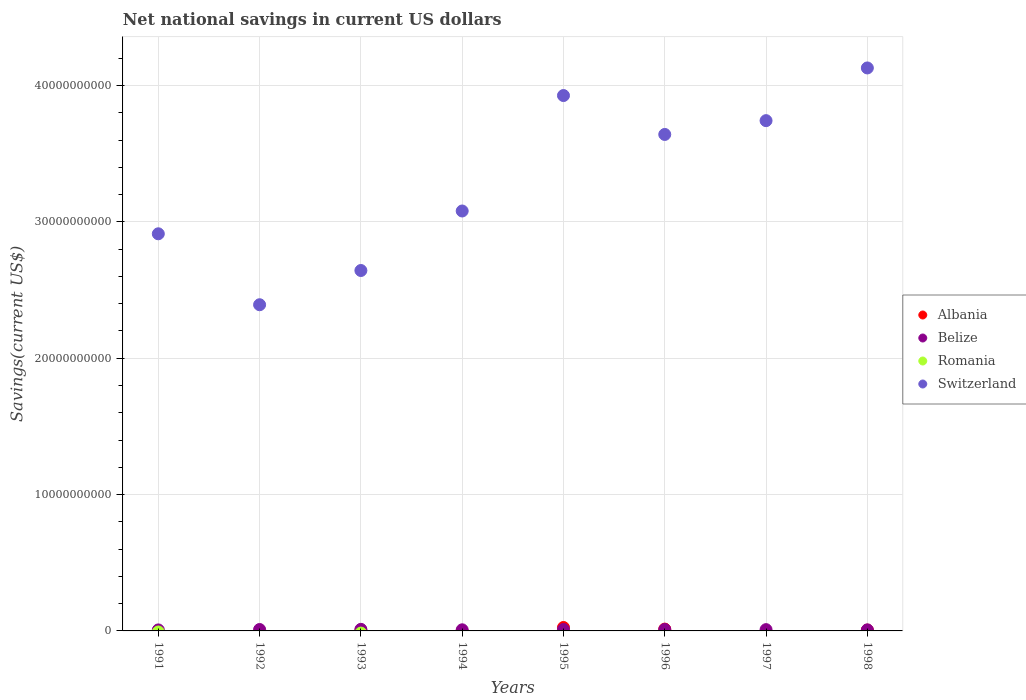How many different coloured dotlines are there?
Offer a terse response. 3. What is the net national savings in Belize in 1994?
Your answer should be compact. 8.16e+07. Across all years, what is the maximum net national savings in Belize?
Your response must be concise. 1.16e+08. Across all years, what is the minimum net national savings in Belize?
Provide a succinct answer. 7.34e+07. What is the total net national savings in Switzerland in the graph?
Keep it short and to the point. 2.65e+11. What is the difference between the net national savings in Switzerland in 1993 and that in 1998?
Your answer should be compact. -1.49e+1. What is the difference between the net national savings in Switzerland in 1991 and the net national savings in Romania in 1992?
Your response must be concise. 2.91e+1. What is the average net national savings in Albania per year?
Offer a very short reply. 5.68e+07. In the year 1991, what is the difference between the net national savings in Belize and net national savings in Switzerland?
Keep it short and to the point. -2.91e+1. What is the ratio of the net national savings in Switzerland in 1993 to that in 1997?
Provide a succinct answer. 0.71. What is the difference between the highest and the second highest net national savings in Belize?
Give a very brief answer. 8.36e+06. What is the difference between the highest and the lowest net national savings in Albania?
Provide a succinct answer. 2.51e+08. In how many years, is the net national savings in Romania greater than the average net national savings in Romania taken over all years?
Your answer should be compact. 0. Is it the case that in every year, the sum of the net national savings in Albania and net national savings in Switzerland  is greater than the net national savings in Belize?
Keep it short and to the point. Yes. What is the difference between two consecutive major ticks on the Y-axis?
Your answer should be very brief. 1.00e+1. Does the graph contain grids?
Your answer should be very brief. Yes. What is the title of the graph?
Provide a short and direct response. Net national savings in current US dollars. What is the label or title of the Y-axis?
Keep it short and to the point. Savings(current US$). What is the Savings(current US$) in Belize in 1991?
Provide a short and direct response. 7.34e+07. What is the Savings(current US$) in Romania in 1991?
Your response must be concise. 0. What is the Savings(current US$) of Switzerland in 1991?
Provide a short and direct response. 2.91e+1. What is the Savings(current US$) in Albania in 1992?
Make the answer very short. 0. What is the Savings(current US$) in Belize in 1992?
Offer a very short reply. 1.03e+08. What is the Savings(current US$) of Switzerland in 1992?
Give a very brief answer. 2.39e+1. What is the Savings(current US$) in Albania in 1993?
Make the answer very short. 1.18e+07. What is the Savings(current US$) of Belize in 1993?
Provide a succinct answer. 1.16e+08. What is the Savings(current US$) of Switzerland in 1993?
Keep it short and to the point. 2.64e+1. What is the Savings(current US$) in Belize in 1994?
Give a very brief answer. 8.16e+07. What is the Savings(current US$) of Switzerland in 1994?
Ensure brevity in your answer.  3.08e+1. What is the Savings(current US$) of Albania in 1995?
Provide a succinct answer. 2.51e+08. What is the Savings(current US$) in Belize in 1995?
Keep it short and to the point. 1.07e+08. What is the Savings(current US$) of Switzerland in 1995?
Provide a succinct answer. 3.93e+1. What is the Savings(current US$) of Albania in 1996?
Give a very brief answer. 1.33e+08. What is the Savings(current US$) of Belize in 1996?
Your response must be concise. 1.06e+08. What is the Savings(current US$) of Romania in 1996?
Give a very brief answer. 0. What is the Savings(current US$) in Switzerland in 1996?
Provide a short and direct response. 3.64e+1. What is the Savings(current US$) in Belize in 1997?
Your response must be concise. 9.42e+07. What is the Savings(current US$) of Romania in 1997?
Give a very brief answer. 0. What is the Savings(current US$) in Switzerland in 1997?
Offer a very short reply. 3.74e+1. What is the Savings(current US$) in Albania in 1998?
Keep it short and to the point. 5.77e+07. What is the Savings(current US$) in Belize in 1998?
Keep it short and to the point. 7.81e+07. What is the Savings(current US$) of Romania in 1998?
Your answer should be very brief. 0. What is the Savings(current US$) in Switzerland in 1998?
Give a very brief answer. 4.13e+1. Across all years, what is the maximum Savings(current US$) in Albania?
Ensure brevity in your answer.  2.51e+08. Across all years, what is the maximum Savings(current US$) of Belize?
Keep it short and to the point. 1.16e+08. Across all years, what is the maximum Savings(current US$) of Switzerland?
Your answer should be very brief. 4.13e+1. Across all years, what is the minimum Savings(current US$) in Albania?
Offer a very short reply. 0. Across all years, what is the minimum Savings(current US$) in Belize?
Ensure brevity in your answer.  7.34e+07. Across all years, what is the minimum Savings(current US$) of Switzerland?
Your answer should be very brief. 2.39e+1. What is the total Savings(current US$) of Albania in the graph?
Your answer should be very brief. 4.54e+08. What is the total Savings(current US$) of Belize in the graph?
Your answer should be compact. 7.60e+08. What is the total Savings(current US$) of Switzerland in the graph?
Your answer should be very brief. 2.65e+11. What is the difference between the Savings(current US$) in Belize in 1991 and that in 1992?
Give a very brief answer. -3.00e+07. What is the difference between the Savings(current US$) of Switzerland in 1991 and that in 1992?
Offer a very short reply. 5.20e+09. What is the difference between the Savings(current US$) in Belize in 1991 and that in 1993?
Make the answer very short. -4.24e+07. What is the difference between the Savings(current US$) of Switzerland in 1991 and that in 1993?
Your answer should be compact. 2.69e+09. What is the difference between the Savings(current US$) in Belize in 1991 and that in 1994?
Make the answer very short. -8.23e+06. What is the difference between the Savings(current US$) of Switzerland in 1991 and that in 1994?
Your answer should be very brief. -1.67e+09. What is the difference between the Savings(current US$) of Belize in 1991 and that in 1995?
Your answer should be compact. -3.41e+07. What is the difference between the Savings(current US$) in Switzerland in 1991 and that in 1995?
Ensure brevity in your answer.  -1.01e+1. What is the difference between the Savings(current US$) of Belize in 1991 and that in 1996?
Your response must be concise. -3.30e+07. What is the difference between the Savings(current US$) of Switzerland in 1991 and that in 1996?
Keep it short and to the point. -7.29e+09. What is the difference between the Savings(current US$) in Belize in 1991 and that in 1997?
Offer a terse response. -2.08e+07. What is the difference between the Savings(current US$) of Switzerland in 1991 and that in 1997?
Provide a succinct answer. -8.30e+09. What is the difference between the Savings(current US$) in Belize in 1991 and that in 1998?
Keep it short and to the point. -4.71e+06. What is the difference between the Savings(current US$) in Switzerland in 1991 and that in 1998?
Keep it short and to the point. -1.22e+1. What is the difference between the Savings(current US$) in Belize in 1992 and that in 1993?
Your response must be concise. -1.25e+07. What is the difference between the Savings(current US$) of Switzerland in 1992 and that in 1993?
Make the answer very short. -2.51e+09. What is the difference between the Savings(current US$) in Belize in 1992 and that in 1994?
Provide a succinct answer. 2.18e+07. What is the difference between the Savings(current US$) of Switzerland in 1992 and that in 1994?
Your answer should be compact. -6.88e+09. What is the difference between the Savings(current US$) in Belize in 1992 and that in 1995?
Offer a very short reply. -4.10e+06. What is the difference between the Savings(current US$) of Switzerland in 1992 and that in 1995?
Give a very brief answer. -1.53e+1. What is the difference between the Savings(current US$) in Belize in 1992 and that in 1996?
Make the answer very short. -3.06e+06. What is the difference between the Savings(current US$) in Switzerland in 1992 and that in 1996?
Provide a short and direct response. -1.25e+1. What is the difference between the Savings(current US$) in Belize in 1992 and that in 1997?
Ensure brevity in your answer.  9.16e+06. What is the difference between the Savings(current US$) in Switzerland in 1992 and that in 1997?
Make the answer very short. -1.35e+1. What is the difference between the Savings(current US$) of Belize in 1992 and that in 1998?
Give a very brief answer. 2.53e+07. What is the difference between the Savings(current US$) in Switzerland in 1992 and that in 1998?
Provide a short and direct response. -1.74e+1. What is the difference between the Savings(current US$) of Belize in 1993 and that in 1994?
Offer a terse response. 3.42e+07. What is the difference between the Savings(current US$) of Switzerland in 1993 and that in 1994?
Provide a short and direct response. -4.37e+09. What is the difference between the Savings(current US$) in Albania in 1993 and that in 1995?
Give a very brief answer. -2.39e+08. What is the difference between the Savings(current US$) of Belize in 1993 and that in 1995?
Offer a terse response. 8.36e+06. What is the difference between the Savings(current US$) in Switzerland in 1993 and that in 1995?
Ensure brevity in your answer.  -1.28e+1. What is the difference between the Savings(current US$) in Albania in 1993 and that in 1996?
Ensure brevity in your answer.  -1.22e+08. What is the difference between the Savings(current US$) in Belize in 1993 and that in 1996?
Your response must be concise. 9.40e+06. What is the difference between the Savings(current US$) in Switzerland in 1993 and that in 1996?
Offer a very short reply. -9.98e+09. What is the difference between the Savings(current US$) in Belize in 1993 and that in 1997?
Provide a succinct answer. 2.16e+07. What is the difference between the Savings(current US$) in Switzerland in 1993 and that in 1997?
Make the answer very short. -1.10e+1. What is the difference between the Savings(current US$) in Albania in 1993 and that in 1998?
Your response must be concise. -4.59e+07. What is the difference between the Savings(current US$) of Belize in 1993 and that in 1998?
Give a very brief answer. 3.77e+07. What is the difference between the Savings(current US$) of Switzerland in 1993 and that in 1998?
Keep it short and to the point. -1.49e+1. What is the difference between the Savings(current US$) of Belize in 1994 and that in 1995?
Provide a short and direct response. -2.59e+07. What is the difference between the Savings(current US$) in Switzerland in 1994 and that in 1995?
Offer a very short reply. -8.47e+09. What is the difference between the Savings(current US$) of Belize in 1994 and that in 1996?
Offer a terse response. -2.48e+07. What is the difference between the Savings(current US$) in Switzerland in 1994 and that in 1996?
Keep it short and to the point. -5.61e+09. What is the difference between the Savings(current US$) of Belize in 1994 and that in 1997?
Make the answer very short. -1.26e+07. What is the difference between the Savings(current US$) in Switzerland in 1994 and that in 1997?
Offer a terse response. -6.63e+09. What is the difference between the Savings(current US$) of Belize in 1994 and that in 1998?
Offer a terse response. 3.52e+06. What is the difference between the Savings(current US$) in Switzerland in 1994 and that in 1998?
Your answer should be compact. -1.05e+1. What is the difference between the Savings(current US$) of Albania in 1995 and that in 1996?
Your answer should be compact. 1.18e+08. What is the difference between the Savings(current US$) in Belize in 1995 and that in 1996?
Your answer should be compact. 1.04e+06. What is the difference between the Savings(current US$) of Switzerland in 1995 and that in 1996?
Provide a succinct answer. 2.85e+09. What is the difference between the Savings(current US$) in Belize in 1995 and that in 1997?
Provide a succinct answer. 1.33e+07. What is the difference between the Savings(current US$) in Switzerland in 1995 and that in 1997?
Your answer should be very brief. 1.84e+09. What is the difference between the Savings(current US$) of Albania in 1995 and that in 1998?
Your response must be concise. 1.94e+08. What is the difference between the Savings(current US$) of Belize in 1995 and that in 1998?
Ensure brevity in your answer.  2.94e+07. What is the difference between the Savings(current US$) in Switzerland in 1995 and that in 1998?
Offer a terse response. -2.02e+09. What is the difference between the Savings(current US$) in Belize in 1996 and that in 1997?
Your answer should be very brief. 1.22e+07. What is the difference between the Savings(current US$) in Switzerland in 1996 and that in 1997?
Give a very brief answer. -1.01e+09. What is the difference between the Savings(current US$) of Albania in 1996 and that in 1998?
Provide a short and direct response. 7.57e+07. What is the difference between the Savings(current US$) in Belize in 1996 and that in 1998?
Provide a succinct answer. 2.83e+07. What is the difference between the Savings(current US$) of Switzerland in 1996 and that in 1998?
Your answer should be very brief. -4.88e+09. What is the difference between the Savings(current US$) of Belize in 1997 and that in 1998?
Your answer should be compact. 1.61e+07. What is the difference between the Savings(current US$) in Switzerland in 1997 and that in 1998?
Offer a very short reply. -3.87e+09. What is the difference between the Savings(current US$) in Belize in 1991 and the Savings(current US$) in Switzerland in 1992?
Your response must be concise. -2.39e+1. What is the difference between the Savings(current US$) in Belize in 1991 and the Savings(current US$) in Switzerland in 1993?
Make the answer very short. -2.64e+1. What is the difference between the Savings(current US$) of Belize in 1991 and the Savings(current US$) of Switzerland in 1994?
Provide a short and direct response. -3.07e+1. What is the difference between the Savings(current US$) of Belize in 1991 and the Savings(current US$) of Switzerland in 1995?
Give a very brief answer. -3.92e+1. What is the difference between the Savings(current US$) in Belize in 1991 and the Savings(current US$) in Switzerland in 1996?
Your answer should be compact. -3.63e+1. What is the difference between the Savings(current US$) in Belize in 1991 and the Savings(current US$) in Switzerland in 1997?
Your answer should be very brief. -3.74e+1. What is the difference between the Savings(current US$) in Belize in 1991 and the Savings(current US$) in Switzerland in 1998?
Offer a very short reply. -4.12e+1. What is the difference between the Savings(current US$) in Belize in 1992 and the Savings(current US$) in Switzerland in 1993?
Offer a very short reply. -2.63e+1. What is the difference between the Savings(current US$) of Belize in 1992 and the Savings(current US$) of Switzerland in 1994?
Provide a succinct answer. -3.07e+1. What is the difference between the Savings(current US$) in Belize in 1992 and the Savings(current US$) in Switzerland in 1995?
Keep it short and to the point. -3.92e+1. What is the difference between the Savings(current US$) of Belize in 1992 and the Savings(current US$) of Switzerland in 1996?
Your answer should be very brief. -3.63e+1. What is the difference between the Savings(current US$) in Belize in 1992 and the Savings(current US$) in Switzerland in 1997?
Make the answer very short. -3.73e+1. What is the difference between the Savings(current US$) of Belize in 1992 and the Savings(current US$) of Switzerland in 1998?
Provide a short and direct response. -4.12e+1. What is the difference between the Savings(current US$) of Albania in 1993 and the Savings(current US$) of Belize in 1994?
Your answer should be very brief. -6.98e+07. What is the difference between the Savings(current US$) in Albania in 1993 and the Savings(current US$) in Switzerland in 1994?
Keep it short and to the point. -3.08e+1. What is the difference between the Savings(current US$) in Belize in 1993 and the Savings(current US$) in Switzerland in 1994?
Provide a succinct answer. -3.07e+1. What is the difference between the Savings(current US$) of Albania in 1993 and the Savings(current US$) of Belize in 1995?
Ensure brevity in your answer.  -9.57e+07. What is the difference between the Savings(current US$) of Albania in 1993 and the Savings(current US$) of Switzerland in 1995?
Make the answer very short. -3.93e+1. What is the difference between the Savings(current US$) of Belize in 1993 and the Savings(current US$) of Switzerland in 1995?
Your answer should be very brief. -3.92e+1. What is the difference between the Savings(current US$) in Albania in 1993 and the Savings(current US$) in Belize in 1996?
Make the answer very short. -9.46e+07. What is the difference between the Savings(current US$) of Albania in 1993 and the Savings(current US$) of Switzerland in 1996?
Provide a short and direct response. -3.64e+1. What is the difference between the Savings(current US$) of Belize in 1993 and the Savings(current US$) of Switzerland in 1996?
Keep it short and to the point. -3.63e+1. What is the difference between the Savings(current US$) in Albania in 1993 and the Savings(current US$) in Belize in 1997?
Provide a short and direct response. -8.24e+07. What is the difference between the Savings(current US$) of Albania in 1993 and the Savings(current US$) of Switzerland in 1997?
Provide a succinct answer. -3.74e+1. What is the difference between the Savings(current US$) of Belize in 1993 and the Savings(current US$) of Switzerland in 1997?
Provide a short and direct response. -3.73e+1. What is the difference between the Savings(current US$) of Albania in 1993 and the Savings(current US$) of Belize in 1998?
Provide a succinct answer. -6.63e+07. What is the difference between the Savings(current US$) of Albania in 1993 and the Savings(current US$) of Switzerland in 1998?
Your response must be concise. -4.13e+1. What is the difference between the Savings(current US$) of Belize in 1993 and the Savings(current US$) of Switzerland in 1998?
Offer a very short reply. -4.12e+1. What is the difference between the Savings(current US$) of Belize in 1994 and the Savings(current US$) of Switzerland in 1995?
Make the answer very short. -3.92e+1. What is the difference between the Savings(current US$) of Belize in 1994 and the Savings(current US$) of Switzerland in 1996?
Provide a succinct answer. -3.63e+1. What is the difference between the Savings(current US$) of Belize in 1994 and the Savings(current US$) of Switzerland in 1997?
Your answer should be very brief. -3.73e+1. What is the difference between the Savings(current US$) in Belize in 1994 and the Savings(current US$) in Switzerland in 1998?
Your response must be concise. -4.12e+1. What is the difference between the Savings(current US$) in Albania in 1995 and the Savings(current US$) in Belize in 1996?
Make the answer very short. 1.45e+08. What is the difference between the Savings(current US$) in Albania in 1995 and the Savings(current US$) in Switzerland in 1996?
Ensure brevity in your answer.  -3.62e+1. What is the difference between the Savings(current US$) in Belize in 1995 and the Savings(current US$) in Switzerland in 1996?
Offer a very short reply. -3.63e+1. What is the difference between the Savings(current US$) of Albania in 1995 and the Savings(current US$) of Belize in 1997?
Give a very brief answer. 1.57e+08. What is the difference between the Savings(current US$) in Albania in 1995 and the Savings(current US$) in Switzerland in 1997?
Your answer should be compact. -3.72e+1. What is the difference between the Savings(current US$) of Belize in 1995 and the Savings(current US$) of Switzerland in 1997?
Make the answer very short. -3.73e+1. What is the difference between the Savings(current US$) of Albania in 1995 and the Savings(current US$) of Belize in 1998?
Make the answer very short. 1.73e+08. What is the difference between the Savings(current US$) in Albania in 1995 and the Savings(current US$) in Switzerland in 1998?
Make the answer very short. -4.10e+1. What is the difference between the Savings(current US$) of Belize in 1995 and the Savings(current US$) of Switzerland in 1998?
Make the answer very short. -4.12e+1. What is the difference between the Savings(current US$) of Albania in 1996 and the Savings(current US$) of Belize in 1997?
Keep it short and to the point. 3.92e+07. What is the difference between the Savings(current US$) of Albania in 1996 and the Savings(current US$) of Switzerland in 1997?
Ensure brevity in your answer.  -3.73e+1. What is the difference between the Savings(current US$) in Belize in 1996 and the Savings(current US$) in Switzerland in 1997?
Offer a terse response. -3.73e+1. What is the difference between the Savings(current US$) in Albania in 1996 and the Savings(current US$) in Belize in 1998?
Keep it short and to the point. 5.53e+07. What is the difference between the Savings(current US$) in Albania in 1996 and the Savings(current US$) in Switzerland in 1998?
Offer a terse response. -4.12e+1. What is the difference between the Savings(current US$) of Belize in 1996 and the Savings(current US$) of Switzerland in 1998?
Offer a very short reply. -4.12e+1. What is the difference between the Savings(current US$) in Belize in 1997 and the Savings(current US$) in Switzerland in 1998?
Offer a very short reply. -4.12e+1. What is the average Savings(current US$) of Albania per year?
Offer a very short reply. 5.68e+07. What is the average Savings(current US$) of Belize per year?
Offer a very short reply. 9.50e+07. What is the average Savings(current US$) in Switzerland per year?
Your answer should be very brief. 3.31e+1. In the year 1991, what is the difference between the Savings(current US$) of Belize and Savings(current US$) of Switzerland?
Give a very brief answer. -2.91e+1. In the year 1992, what is the difference between the Savings(current US$) of Belize and Savings(current US$) of Switzerland?
Your answer should be compact. -2.38e+1. In the year 1993, what is the difference between the Savings(current US$) in Albania and Savings(current US$) in Belize?
Keep it short and to the point. -1.04e+08. In the year 1993, what is the difference between the Savings(current US$) of Albania and Savings(current US$) of Switzerland?
Offer a very short reply. -2.64e+1. In the year 1993, what is the difference between the Savings(current US$) in Belize and Savings(current US$) in Switzerland?
Keep it short and to the point. -2.63e+1. In the year 1994, what is the difference between the Savings(current US$) of Belize and Savings(current US$) of Switzerland?
Ensure brevity in your answer.  -3.07e+1. In the year 1995, what is the difference between the Savings(current US$) in Albania and Savings(current US$) in Belize?
Your answer should be compact. 1.44e+08. In the year 1995, what is the difference between the Savings(current US$) in Albania and Savings(current US$) in Switzerland?
Offer a terse response. -3.90e+1. In the year 1995, what is the difference between the Savings(current US$) in Belize and Savings(current US$) in Switzerland?
Provide a short and direct response. -3.92e+1. In the year 1996, what is the difference between the Savings(current US$) in Albania and Savings(current US$) in Belize?
Provide a short and direct response. 2.70e+07. In the year 1996, what is the difference between the Savings(current US$) in Albania and Savings(current US$) in Switzerland?
Provide a succinct answer. -3.63e+1. In the year 1996, what is the difference between the Savings(current US$) in Belize and Savings(current US$) in Switzerland?
Provide a succinct answer. -3.63e+1. In the year 1997, what is the difference between the Savings(current US$) of Belize and Savings(current US$) of Switzerland?
Your answer should be compact. -3.73e+1. In the year 1998, what is the difference between the Savings(current US$) of Albania and Savings(current US$) of Belize?
Offer a terse response. -2.04e+07. In the year 1998, what is the difference between the Savings(current US$) of Albania and Savings(current US$) of Switzerland?
Provide a succinct answer. -4.12e+1. In the year 1998, what is the difference between the Savings(current US$) in Belize and Savings(current US$) in Switzerland?
Offer a terse response. -4.12e+1. What is the ratio of the Savings(current US$) of Belize in 1991 to that in 1992?
Keep it short and to the point. 0.71. What is the ratio of the Savings(current US$) in Switzerland in 1991 to that in 1992?
Give a very brief answer. 1.22. What is the ratio of the Savings(current US$) of Belize in 1991 to that in 1993?
Offer a terse response. 0.63. What is the ratio of the Savings(current US$) in Switzerland in 1991 to that in 1993?
Give a very brief answer. 1.1. What is the ratio of the Savings(current US$) in Belize in 1991 to that in 1994?
Keep it short and to the point. 0.9. What is the ratio of the Savings(current US$) of Switzerland in 1991 to that in 1994?
Your response must be concise. 0.95. What is the ratio of the Savings(current US$) in Belize in 1991 to that in 1995?
Offer a terse response. 0.68. What is the ratio of the Savings(current US$) in Switzerland in 1991 to that in 1995?
Provide a succinct answer. 0.74. What is the ratio of the Savings(current US$) of Belize in 1991 to that in 1996?
Give a very brief answer. 0.69. What is the ratio of the Savings(current US$) in Switzerland in 1991 to that in 1996?
Your response must be concise. 0.8. What is the ratio of the Savings(current US$) of Belize in 1991 to that in 1997?
Offer a very short reply. 0.78. What is the ratio of the Savings(current US$) in Switzerland in 1991 to that in 1997?
Ensure brevity in your answer.  0.78. What is the ratio of the Savings(current US$) in Belize in 1991 to that in 1998?
Your answer should be compact. 0.94. What is the ratio of the Savings(current US$) in Switzerland in 1991 to that in 1998?
Offer a terse response. 0.71. What is the ratio of the Savings(current US$) in Belize in 1992 to that in 1993?
Give a very brief answer. 0.89. What is the ratio of the Savings(current US$) in Switzerland in 1992 to that in 1993?
Provide a short and direct response. 0.91. What is the ratio of the Savings(current US$) in Belize in 1992 to that in 1994?
Give a very brief answer. 1.27. What is the ratio of the Savings(current US$) of Switzerland in 1992 to that in 1994?
Offer a terse response. 0.78. What is the ratio of the Savings(current US$) of Belize in 1992 to that in 1995?
Your response must be concise. 0.96. What is the ratio of the Savings(current US$) in Switzerland in 1992 to that in 1995?
Offer a very short reply. 0.61. What is the ratio of the Savings(current US$) of Belize in 1992 to that in 1996?
Your answer should be compact. 0.97. What is the ratio of the Savings(current US$) in Switzerland in 1992 to that in 1996?
Your response must be concise. 0.66. What is the ratio of the Savings(current US$) of Belize in 1992 to that in 1997?
Keep it short and to the point. 1.1. What is the ratio of the Savings(current US$) of Switzerland in 1992 to that in 1997?
Ensure brevity in your answer.  0.64. What is the ratio of the Savings(current US$) in Belize in 1992 to that in 1998?
Your response must be concise. 1.32. What is the ratio of the Savings(current US$) in Switzerland in 1992 to that in 1998?
Give a very brief answer. 0.58. What is the ratio of the Savings(current US$) of Belize in 1993 to that in 1994?
Offer a very short reply. 1.42. What is the ratio of the Savings(current US$) in Switzerland in 1993 to that in 1994?
Your answer should be compact. 0.86. What is the ratio of the Savings(current US$) in Albania in 1993 to that in 1995?
Your response must be concise. 0.05. What is the ratio of the Savings(current US$) of Belize in 1993 to that in 1995?
Make the answer very short. 1.08. What is the ratio of the Savings(current US$) in Switzerland in 1993 to that in 1995?
Give a very brief answer. 0.67. What is the ratio of the Savings(current US$) in Albania in 1993 to that in 1996?
Offer a terse response. 0.09. What is the ratio of the Savings(current US$) of Belize in 1993 to that in 1996?
Your response must be concise. 1.09. What is the ratio of the Savings(current US$) of Switzerland in 1993 to that in 1996?
Provide a short and direct response. 0.73. What is the ratio of the Savings(current US$) in Belize in 1993 to that in 1997?
Make the answer very short. 1.23. What is the ratio of the Savings(current US$) of Switzerland in 1993 to that in 1997?
Offer a very short reply. 0.71. What is the ratio of the Savings(current US$) of Albania in 1993 to that in 1998?
Provide a short and direct response. 0.2. What is the ratio of the Savings(current US$) in Belize in 1993 to that in 1998?
Ensure brevity in your answer.  1.48. What is the ratio of the Savings(current US$) in Switzerland in 1993 to that in 1998?
Your answer should be compact. 0.64. What is the ratio of the Savings(current US$) in Belize in 1994 to that in 1995?
Ensure brevity in your answer.  0.76. What is the ratio of the Savings(current US$) in Switzerland in 1994 to that in 1995?
Offer a terse response. 0.78. What is the ratio of the Savings(current US$) in Belize in 1994 to that in 1996?
Keep it short and to the point. 0.77. What is the ratio of the Savings(current US$) of Switzerland in 1994 to that in 1996?
Your response must be concise. 0.85. What is the ratio of the Savings(current US$) in Belize in 1994 to that in 1997?
Keep it short and to the point. 0.87. What is the ratio of the Savings(current US$) in Switzerland in 1994 to that in 1997?
Offer a terse response. 0.82. What is the ratio of the Savings(current US$) of Belize in 1994 to that in 1998?
Ensure brevity in your answer.  1.05. What is the ratio of the Savings(current US$) in Switzerland in 1994 to that in 1998?
Ensure brevity in your answer.  0.75. What is the ratio of the Savings(current US$) in Albania in 1995 to that in 1996?
Your answer should be very brief. 1.88. What is the ratio of the Savings(current US$) of Belize in 1995 to that in 1996?
Your answer should be compact. 1.01. What is the ratio of the Savings(current US$) of Switzerland in 1995 to that in 1996?
Provide a short and direct response. 1.08. What is the ratio of the Savings(current US$) of Belize in 1995 to that in 1997?
Keep it short and to the point. 1.14. What is the ratio of the Savings(current US$) of Switzerland in 1995 to that in 1997?
Keep it short and to the point. 1.05. What is the ratio of the Savings(current US$) in Albania in 1995 to that in 1998?
Keep it short and to the point. 4.36. What is the ratio of the Savings(current US$) of Belize in 1995 to that in 1998?
Offer a terse response. 1.38. What is the ratio of the Savings(current US$) of Switzerland in 1995 to that in 1998?
Give a very brief answer. 0.95. What is the ratio of the Savings(current US$) in Belize in 1996 to that in 1997?
Your response must be concise. 1.13. What is the ratio of the Savings(current US$) of Switzerland in 1996 to that in 1997?
Provide a succinct answer. 0.97. What is the ratio of the Savings(current US$) of Albania in 1996 to that in 1998?
Provide a succinct answer. 2.31. What is the ratio of the Savings(current US$) in Belize in 1996 to that in 1998?
Provide a short and direct response. 1.36. What is the ratio of the Savings(current US$) in Switzerland in 1996 to that in 1998?
Offer a very short reply. 0.88. What is the ratio of the Savings(current US$) in Belize in 1997 to that in 1998?
Keep it short and to the point. 1.21. What is the ratio of the Savings(current US$) in Switzerland in 1997 to that in 1998?
Offer a very short reply. 0.91. What is the difference between the highest and the second highest Savings(current US$) of Albania?
Provide a short and direct response. 1.18e+08. What is the difference between the highest and the second highest Savings(current US$) in Belize?
Give a very brief answer. 8.36e+06. What is the difference between the highest and the second highest Savings(current US$) in Switzerland?
Make the answer very short. 2.02e+09. What is the difference between the highest and the lowest Savings(current US$) of Albania?
Make the answer very short. 2.51e+08. What is the difference between the highest and the lowest Savings(current US$) in Belize?
Give a very brief answer. 4.24e+07. What is the difference between the highest and the lowest Savings(current US$) in Switzerland?
Make the answer very short. 1.74e+1. 